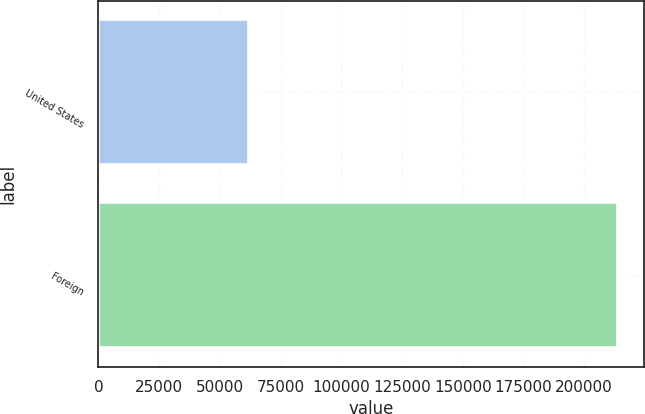<chart> <loc_0><loc_0><loc_500><loc_500><bar_chart><fcel>United States<fcel>Foreign<nl><fcel>61818<fcel>213848<nl></chart> 